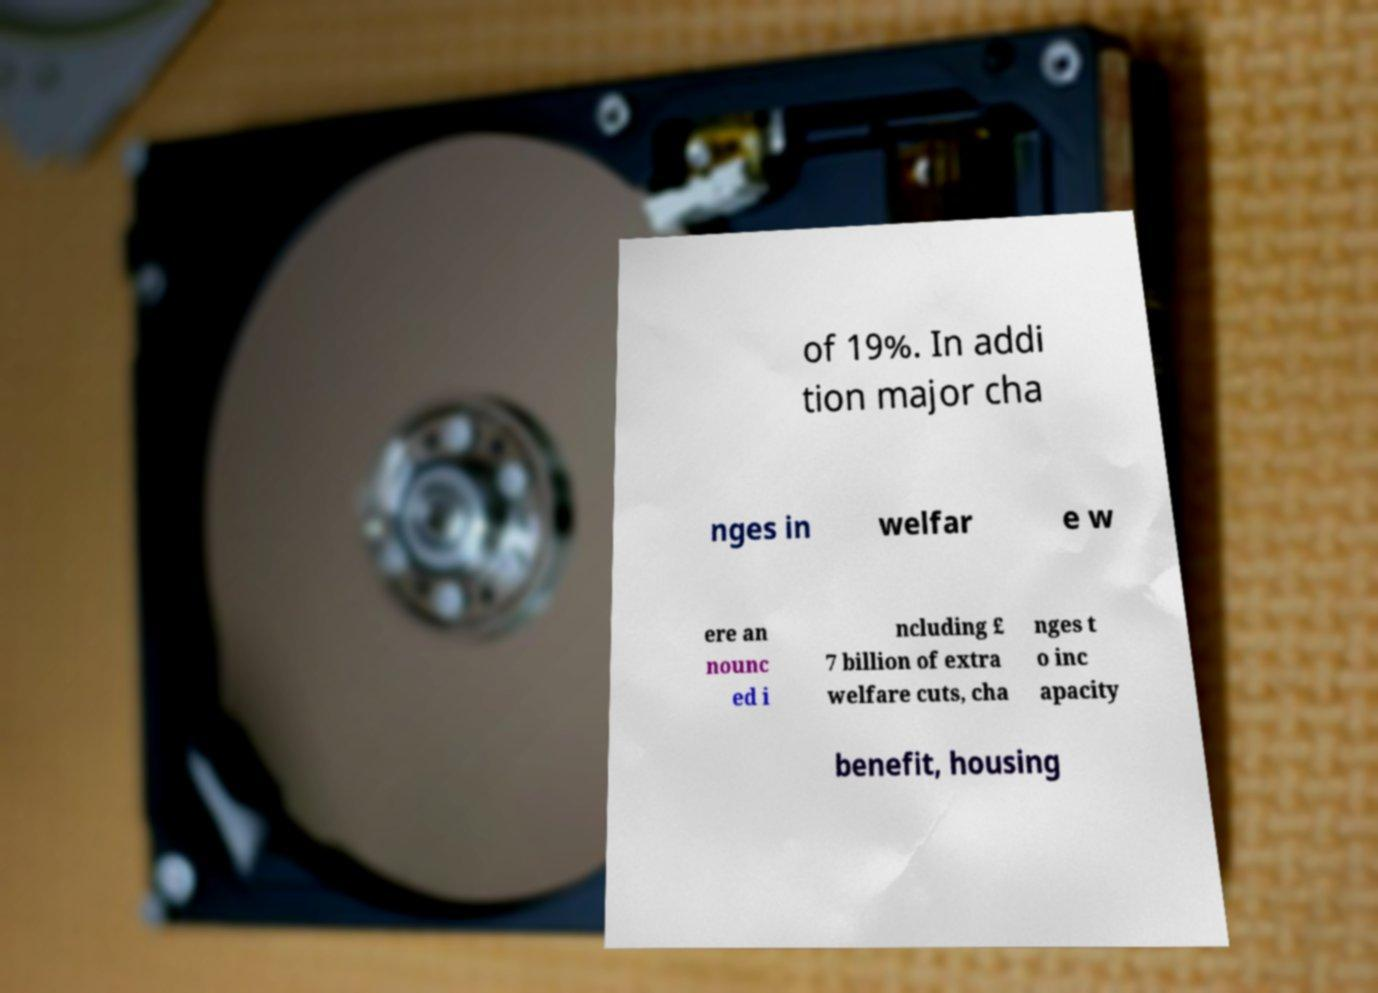Please read and relay the text visible in this image. What does it say? of 19%. In addi tion major cha nges in welfar e w ere an nounc ed i ncluding £ 7 billion of extra welfare cuts, cha nges t o inc apacity benefit, housing 